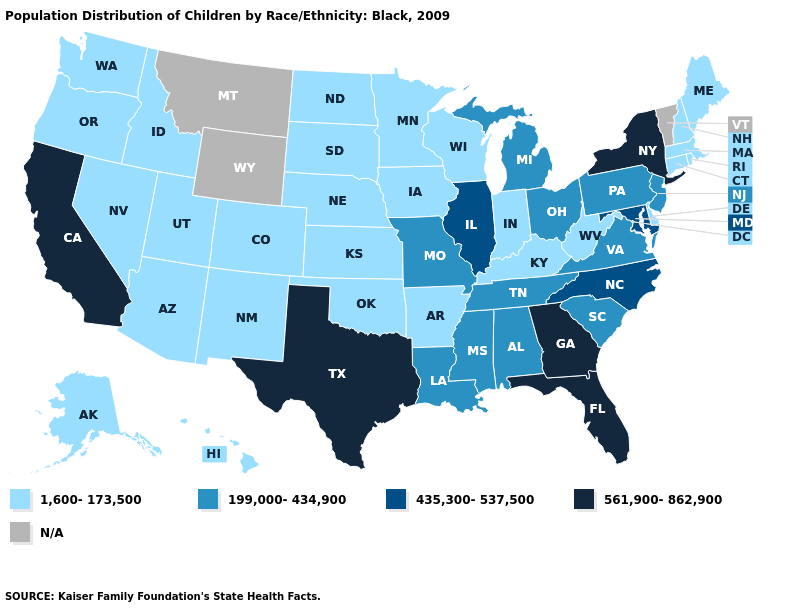What is the value of Montana?
Short answer required. N/A. Name the states that have a value in the range 561,900-862,900?
Quick response, please. California, Florida, Georgia, New York, Texas. What is the lowest value in the South?
Give a very brief answer. 1,600-173,500. Name the states that have a value in the range N/A?
Give a very brief answer. Montana, Vermont, Wyoming. Name the states that have a value in the range 435,300-537,500?
Be succinct. Illinois, Maryland, North Carolina. Does North Dakota have the highest value in the USA?
Be succinct. No. Name the states that have a value in the range 199,000-434,900?
Quick response, please. Alabama, Louisiana, Michigan, Mississippi, Missouri, New Jersey, Ohio, Pennsylvania, South Carolina, Tennessee, Virginia. Does Washington have the highest value in the USA?
Short answer required. No. Which states have the highest value in the USA?
Quick response, please. California, Florida, Georgia, New York, Texas. What is the lowest value in the USA?
Concise answer only. 1,600-173,500. How many symbols are there in the legend?
Short answer required. 5. Which states have the lowest value in the USA?
Answer briefly. Alaska, Arizona, Arkansas, Colorado, Connecticut, Delaware, Hawaii, Idaho, Indiana, Iowa, Kansas, Kentucky, Maine, Massachusetts, Minnesota, Nebraska, Nevada, New Hampshire, New Mexico, North Dakota, Oklahoma, Oregon, Rhode Island, South Dakota, Utah, Washington, West Virginia, Wisconsin. Name the states that have a value in the range 561,900-862,900?
Be succinct. California, Florida, Georgia, New York, Texas. 